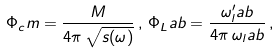Convert formula to latex. <formula><loc_0><loc_0><loc_500><loc_500>\Phi _ { c } m = \frac { M } { 4 \pi \, \sqrt { s ( \omega ) } } \, , \, \Phi _ { L } a b = \frac { \omega ^ { \prime } _ { l } a b } { 4 \pi \, \omega _ { l } a b } \, ,</formula> 